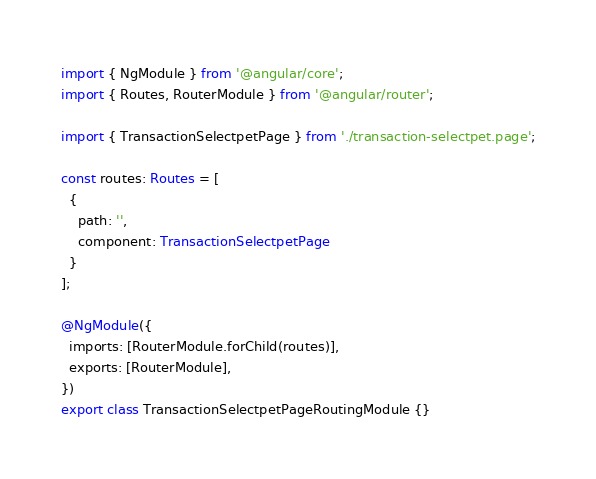Convert code to text. <code><loc_0><loc_0><loc_500><loc_500><_TypeScript_>import { NgModule } from '@angular/core';
import { Routes, RouterModule } from '@angular/router';

import { TransactionSelectpetPage } from './transaction-selectpet.page';

const routes: Routes = [
  {
    path: '',
    component: TransactionSelectpetPage
  }
];

@NgModule({
  imports: [RouterModule.forChild(routes)],
  exports: [RouterModule],
})
export class TransactionSelectpetPageRoutingModule {}
</code> 